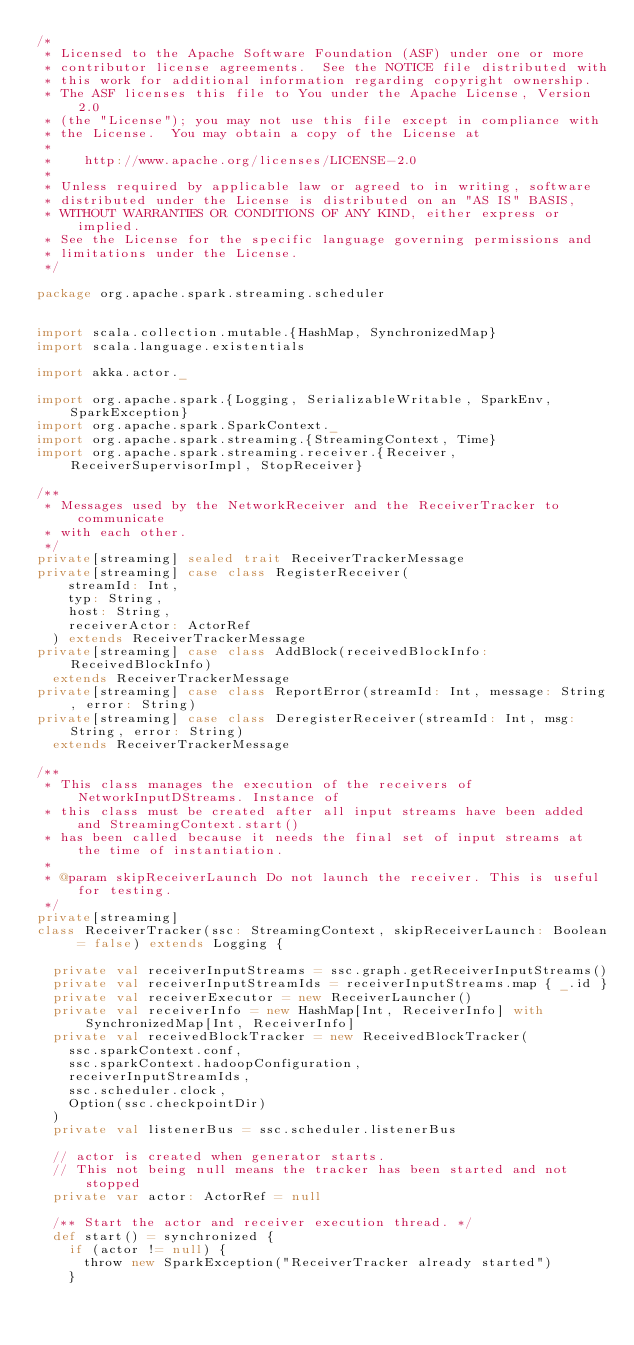Convert code to text. <code><loc_0><loc_0><loc_500><loc_500><_Scala_>/*
 * Licensed to the Apache Software Foundation (ASF) under one or more
 * contributor license agreements.  See the NOTICE file distributed with
 * this work for additional information regarding copyright ownership.
 * The ASF licenses this file to You under the Apache License, Version 2.0
 * (the "License"); you may not use this file except in compliance with
 * the License.  You may obtain a copy of the License at
 *
 *    http://www.apache.org/licenses/LICENSE-2.0
 *
 * Unless required by applicable law or agreed to in writing, software
 * distributed under the License is distributed on an "AS IS" BASIS,
 * WITHOUT WARRANTIES OR CONDITIONS OF ANY KIND, either express or implied.
 * See the License for the specific language governing permissions and
 * limitations under the License.
 */

package org.apache.spark.streaming.scheduler


import scala.collection.mutable.{HashMap, SynchronizedMap}
import scala.language.existentials

import akka.actor._

import org.apache.spark.{Logging, SerializableWritable, SparkEnv, SparkException}
import org.apache.spark.SparkContext._
import org.apache.spark.streaming.{StreamingContext, Time}
import org.apache.spark.streaming.receiver.{Receiver, ReceiverSupervisorImpl, StopReceiver}

/**
 * Messages used by the NetworkReceiver and the ReceiverTracker to communicate
 * with each other.
 */
private[streaming] sealed trait ReceiverTrackerMessage
private[streaming] case class RegisterReceiver(
    streamId: Int,
    typ: String,
    host: String,
    receiverActor: ActorRef
  ) extends ReceiverTrackerMessage
private[streaming] case class AddBlock(receivedBlockInfo: ReceivedBlockInfo)
  extends ReceiverTrackerMessage
private[streaming] case class ReportError(streamId: Int, message: String, error: String)
private[streaming] case class DeregisterReceiver(streamId: Int, msg: String, error: String)
  extends ReceiverTrackerMessage

/**
 * This class manages the execution of the receivers of NetworkInputDStreams. Instance of
 * this class must be created after all input streams have been added and StreamingContext.start()
 * has been called because it needs the final set of input streams at the time of instantiation.
 *
 * @param skipReceiverLaunch Do not launch the receiver. This is useful for testing.
 */
private[streaming]
class ReceiverTracker(ssc: StreamingContext, skipReceiverLaunch: Boolean = false) extends Logging {

  private val receiverInputStreams = ssc.graph.getReceiverInputStreams()
  private val receiverInputStreamIds = receiverInputStreams.map { _.id }
  private val receiverExecutor = new ReceiverLauncher()
  private val receiverInfo = new HashMap[Int, ReceiverInfo] with SynchronizedMap[Int, ReceiverInfo]
  private val receivedBlockTracker = new ReceivedBlockTracker(
    ssc.sparkContext.conf,
    ssc.sparkContext.hadoopConfiguration,
    receiverInputStreamIds,
    ssc.scheduler.clock,
    Option(ssc.checkpointDir)
  )
  private val listenerBus = ssc.scheduler.listenerBus

  // actor is created when generator starts.
  // This not being null means the tracker has been started and not stopped
  private var actor: ActorRef = null

  /** Start the actor and receiver execution thread. */
  def start() = synchronized {
    if (actor != null) {
      throw new SparkException("ReceiverTracker already started")
    }
</code> 